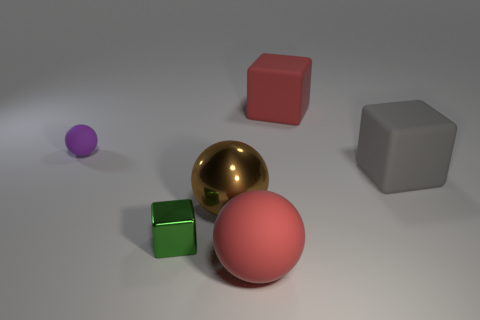There is a ball that is both behind the big rubber sphere and on the right side of the green block; what size is it?
Your response must be concise. Large. What is the material of the brown thing that is the same shape as the purple object?
Make the answer very short. Metal. What is the block that is on the right side of the red thing behind the large matte sphere made of?
Offer a terse response. Rubber. There is a large shiny object; does it have the same shape as the red matte thing that is behind the small block?
Your answer should be very brief. No. What number of matte objects are either tiny green cubes or large objects?
Make the answer very short. 3. What color is the big block right of the large red matte thing that is behind the matte sphere behind the green shiny block?
Provide a short and direct response. Gray. How many other objects are there of the same material as the tiny ball?
Provide a short and direct response. 3. There is a object behind the small purple matte sphere; does it have the same shape as the big gray matte object?
Make the answer very short. Yes. What number of small things are matte spheres or red cylinders?
Make the answer very short. 1. Is the number of red spheres that are on the left side of the small metal cube the same as the number of large red things that are behind the gray thing?
Your response must be concise. No. 